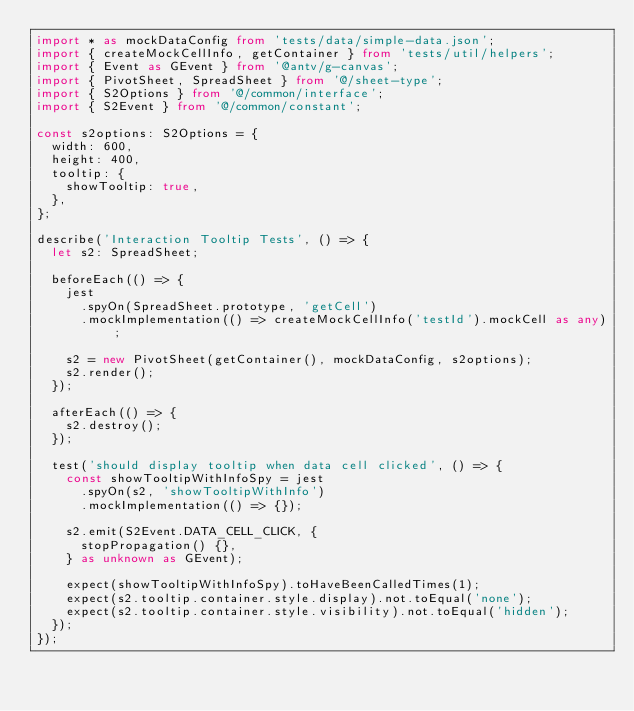<code> <loc_0><loc_0><loc_500><loc_500><_TypeScript_>import * as mockDataConfig from 'tests/data/simple-data.json';
import { createMockCellInfo, getContainer } from 'tests/util/helpers';
import { Event as GEvent } from '@antv/g-canvas';
import { PivotSheet, SpreadSheet } from '@/sheet-type';
import { S2Options } from '@/common/interface';
import { S2Event } from '@/common/constant';

const s2options: S2Options = {
  width: 600,
  height: 400,
  tooltip: {
    showTooltip: true,
  },
};

describe('Interaction Tooltip Tests', () => {
  let s2: SpreadSheet;

  beforeEach(() => {
    jest
      .spyOn(SpreadSheet.prototype, 'getCell')
      .mockImplementation(() => createMockCellInfo('testId').mockCell as any);

    s2 = new PivotSheet(getContainer(), mockDataConfig, s2options);
    s2.render();
  });

  afterEach(() => {
    s2.destroy();
  });

  test('should display tooltip when data cell clicked', () => {
    const showTooltipWithInfoSpy = jest
      .spyOn(s2, 'showTooltipWithInfo')
      .mockImplementation(() => {});

    s2.emit(S2Event.DATA_CELL_CLICK, {
      stopPropagation() {},
    } as unknown as GEvent);

    expect(showTooltipWithInfoSpy).toHaveBeenCalledTimes(1);
    expect(s2.tooltip.container.style.display).not.toEqual('none');
    expect(s2.tooltip.container.style.visibility).not.toEqual('hidden');
  });
});
</code> 